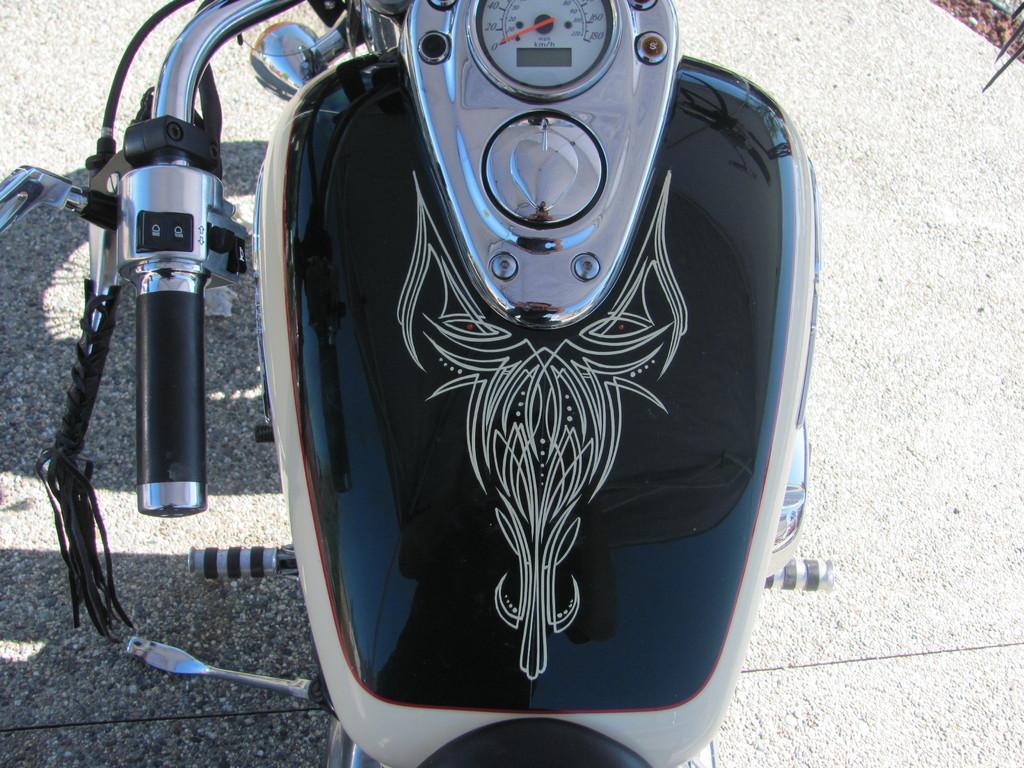Could you give a brief overview of what you see in this image? In the middle of this image, there is a bike parked on a road. This bike has had a speedometer. And the background is gray in color. 